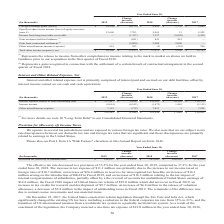According to Opentext Corporation's financial document, What is the income (expense) from foreign exchange is dependent on? Based on the financial document, the answer is the change in foreign currency exchange rates vis-àvis the functional currency of the legal entity.. Also, What years are included in the table? The document contains multiple relevant values: 2019, 2018, 2017. From the document: "Change increase (decrease) 2017 (In thousands) 2019 Change increase (decrease) 2018..." Also, What are the units used in the table? According to the financial document, thousands. The relevant text states: "(In thousands) 2019..." Also, can you calculate: What is the average annual Total other income (expense), net? To answer this question, I need to perform calculations using the financial data. The calculation is: (10,156+17,973+15,743)/3, which equals 14624 (in thousands). This is based on the information: "other income (expense), net $ 10,156 $ (7,817) $ 17,973 $ 2,230 $ 15,743 Total other income (expense), net $ 10,156 $ (7,817) $ 17,973 $ 2,230 $ 15,743 pense), net $ 10,156 $ (7,817) $ 17,973 $ 2,230 ..." The key data points involved are: 10,156, 15,743, 17,973. Also, can you calculate: What is the percentage change of Total other income (expense), net for fiscal year 2018 to 2019? To answer this question, I need to perform calculations using the financial data. The calculation is: -7,817/17,973, which equals -43.49 (percentage). This is based on the information: "other income (expense), net $ 10,156 $ (7,817) $ 17,973 $ 2,230 $ 15,743 Total other income (expense), net $ 10,156 $ (7,817) $ 17,973 $ 2,230 $ 15,743..." The key data points involved are: 17,973, 7,817. Also, can you calculate: What is the change of Total other income (expense), net from fiscal year 2017 to 2019? Based on the calculation: -7,817+2,230, the result is -5587 (in thousands). This is based on the information: "come (expense), net $ 10,156 $ (7,817) $ 17,973 $ 2,230 $ 15,743 Total other income (expense), net $ 10,156 $ (7,817) $ 17,973 $ 2,230 $ 15,743..." The key data points involved are: 2,230, 7,817. 